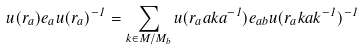Convert formula to latex. <formula><loc_0><loc_0><loc_500><loc_500>u ( r _ { a } ) e _ { a } u ( r _ { a } ) ^ { - 1 } = \sum _ { k \in M / M _ { b } } u ( r _ { a } a k a ^ { - 1 } ) e _ { a b } u ( r _ { a } k a k ^ { - 1 } ) ^ { - 1 }</formula> 